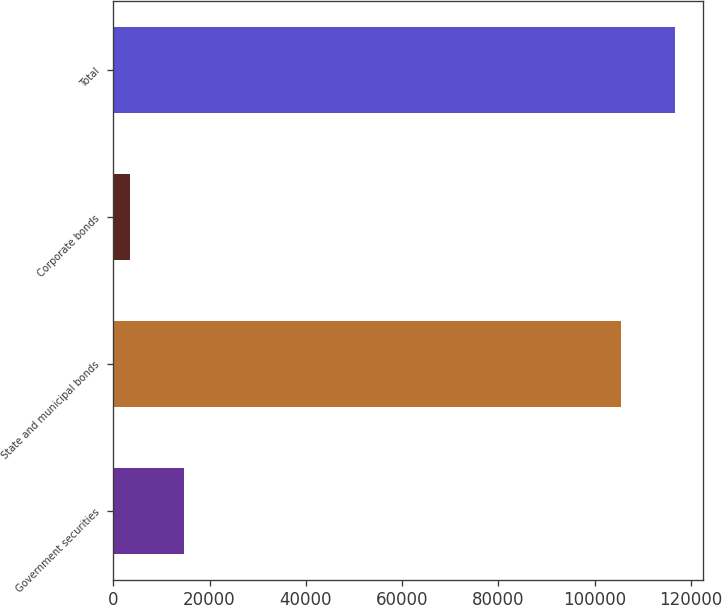Convert chart to OTSL. <chart><loc_0><loc_0><loc_500><loc_500><bar_chart><fcel>Government securities<fcel>State and municipal bonds<fcel>Corporate bonds<fcel>Total<nl><fcel>14697<fcel>105499<fcel>3555<fcel>116641<nl></chart> 